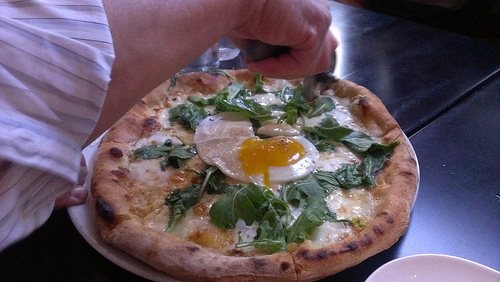Are there pomegranates or burritos? No, there are no pomegranates or burritos in the image. 